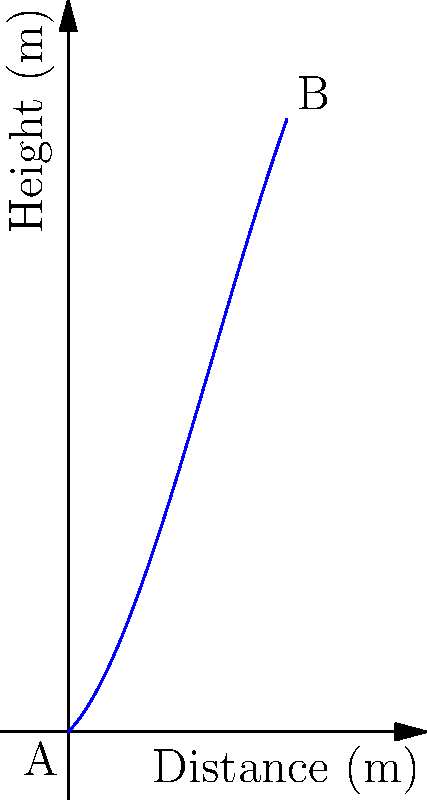As a dedicated Scone Thistle supporter, you're analyzing a spectacular free kick from your star player. The path of the ball can be modeled by the polynomial function $h(x) = -0.05x^3 + 0.6x^2 + x$, where $x$ is the horizontal distance from the kick point in meters, and $h(x)$ is the height of the ball in meters. What is the maximum height reached by the ball during its flight? To find the maximum height of the ball, we need to follow these steps:

1) The maximum height occurs where the derivative of the function is zero. Let's find the derivative:

   $h'(x) = -0.15x^2 + 1.2x + 1$

2) Set the derivative to zero and solve for x:

   $-0.15x^2 + 1.2x + 1 = 0$

3) This is a quadratic equation. We can solve it using the quadratic formula:

   $x = \frac{-b \pm \sqrt{b^2 - 4ac}}{2a}$

   Where $a = -0.15$, $b = 1.2$, and $c = 1$

4) Plugging in these values:

   $x = \frac{-1.2 \pm \sqrt{1.44 - 4(-0.15)(1)}}{2(-0.15)}$

5) Simplifying:

   $x = \frac{-1.2 \pm \sqrt{2.04}}{-0.3} = \frac{-1.2 \pm 1.428}{-0.3}$

6) This gives us two solutions:
   
   $x_1 = \frac{-1.2 + 1.428}{-0.3} = -0.76$
   $x_2 = \frac{-1.2 - 1.428}{-0.3} = 8.76$

7) Since we're dealing with a physical situation where x represents distance, we can discard the negative solution. Therefore, the maximum occurs at x ≈ 4.76 meters.

8) To find the maximum height, we plug this x-value back into our original function:

   $h(4.76) = -0.05(4.76)^3 + 0.6(4.76)^2 + 4.76 ≈ 7.15$

Therefore, the maximum height reached by the ball is approximately 7.15 meters.
Answer: 7.15 meters 